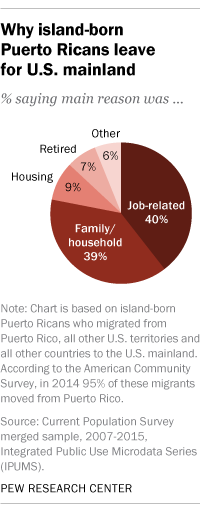Highlight a few significant elements in this photo. The darkest-colored segment in the range of 40.. has a percentage value. How many segments have a value above 30%? There are two segments that meet this criteria. 